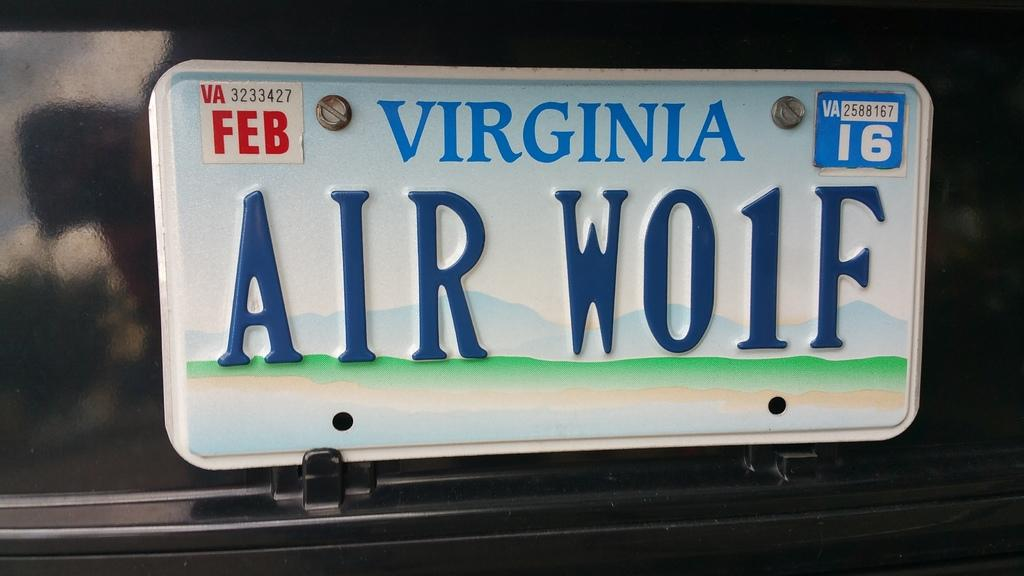What can be seen in the image related to vehicle identification? There is a number plate in the image. What information is present on the number plate? Something is written on the number plate. What brand of toothpaste is advertised at the airport in the image? There is no toothpaste or airport present in the image; it only features a number plate with something written on it. 